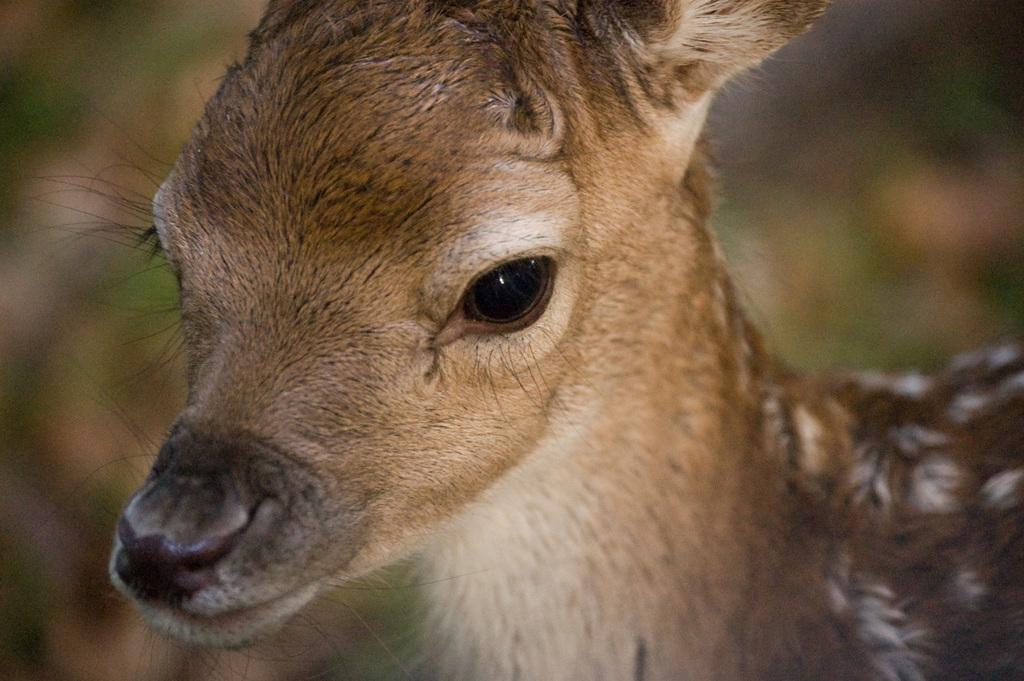What animal is the main subject of the picture? There is a deer in the picture. Where is the deer located in the image? The deer is in the middle of the picture. What color is the deer? The deer is brown in color. How would you describe the background of the image? The background of the image is blurred. What type of pancake is the deer holding in the image? There is no pancake present in the image, and the deer is not holding anything. 